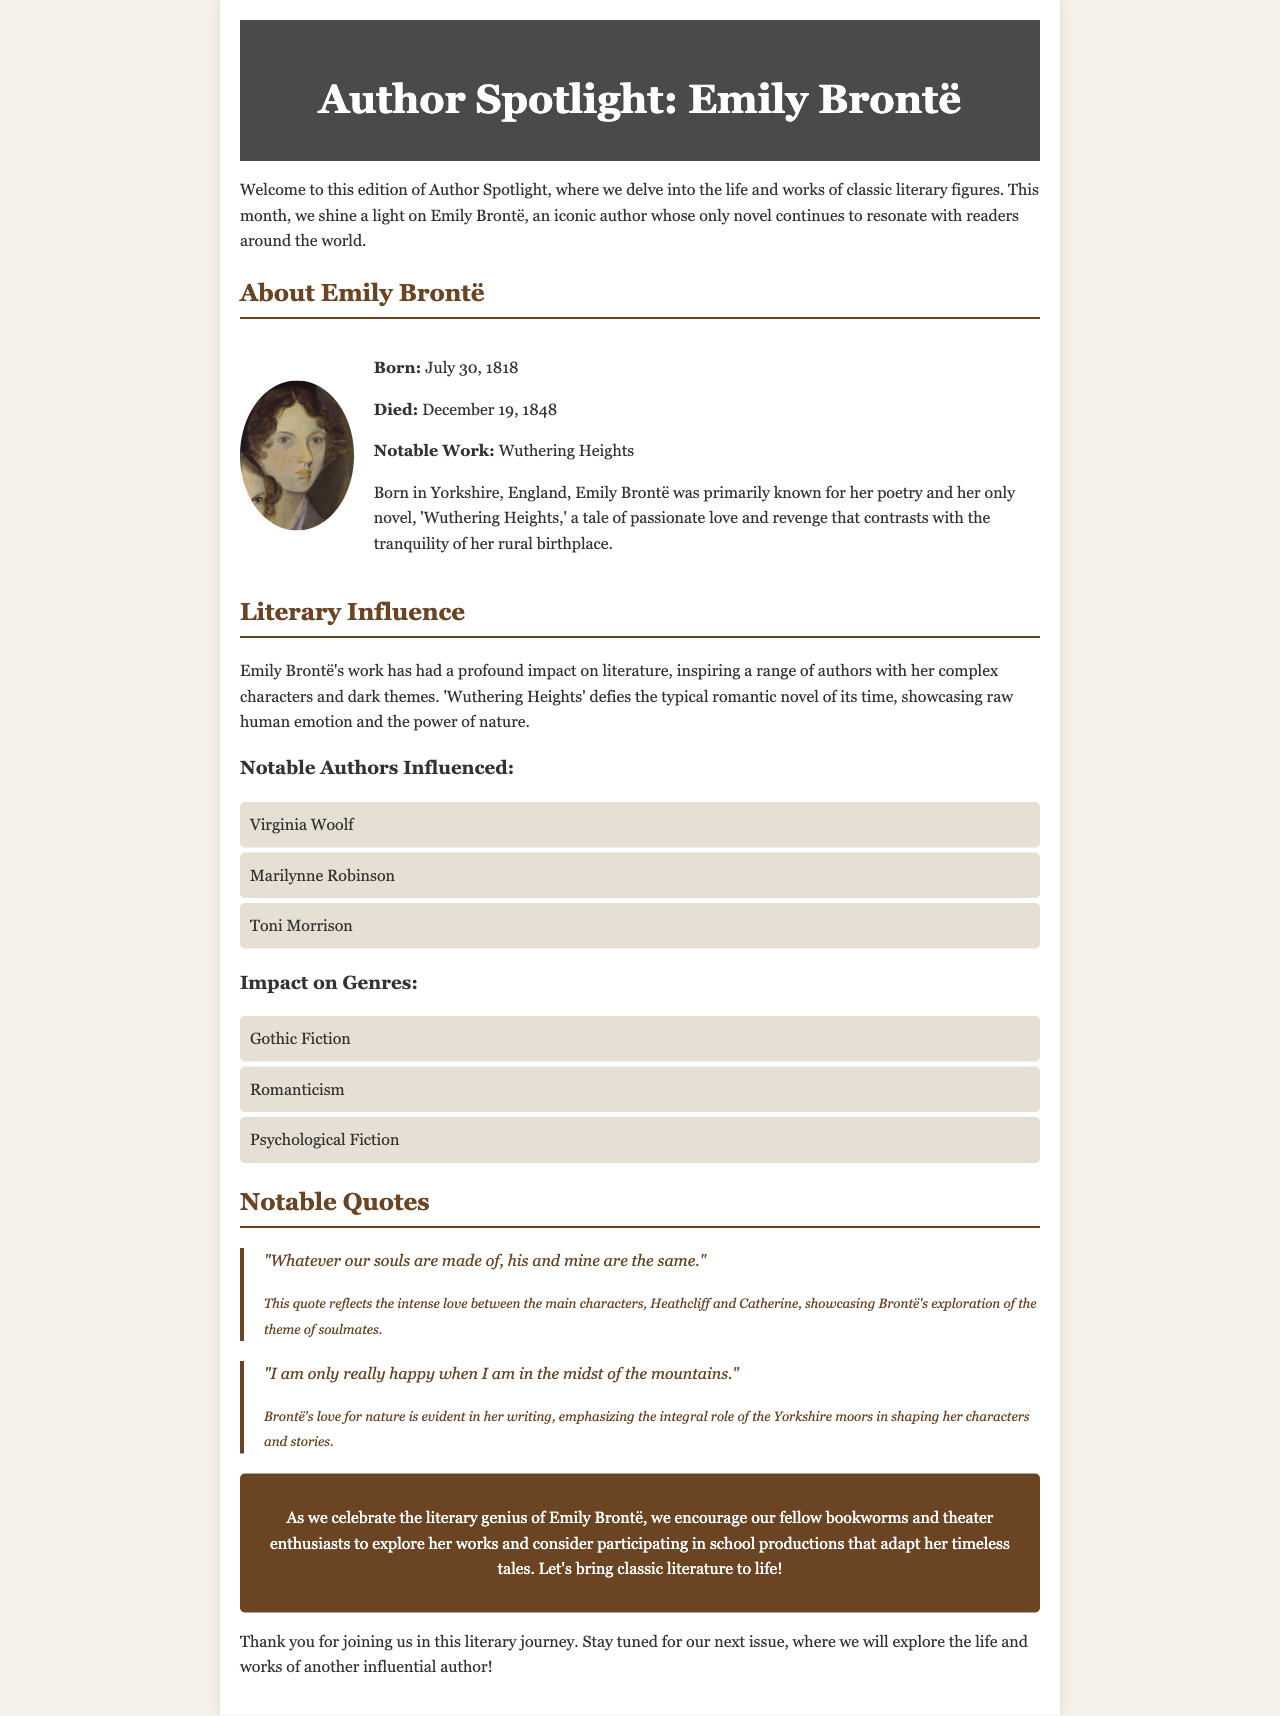What is the title of the newsletter? The title of the newsletter is presented at the top section of the document.
Answer: Author Spotlight: Emily Brontë When was Emily Brontë born? The document includes specific details about Emily Brontë's birth date.
Answer: July 30, 1818 What is the notable work of Emily Brontë? The document mentions the prominent work associated with Emily Brontë.
Answer: Wuthering Heights Which genre did Emily Brontë influence? The document lists genres impacted by Emily Brontë, highlighting gothic fiction.
Answer: Gothic Fiction What is one of the notable quotes by Emily Brontë? The document features two quotes from Emily Brontë, capturing her themes of love and nature.
Answer: "Whatever our souls are made of, his and mine are the same." Who are two authors influenced by Emily Brontë? The document lists specific authors who have been inspired by Emily Brontë's work.
Answer: Virginia Woolf, Toni Morrison What significant theme is explored in 'Wuthering Heights'? The document discusses themes present in 'Wuthering Heights,' focusing on love and nature.
Answer: Passionate love What should readers consider doing after exploring Brontë's works? The call to action encourages a specific activity related to literature and theater after reading.
Answer: Participating in school productions 